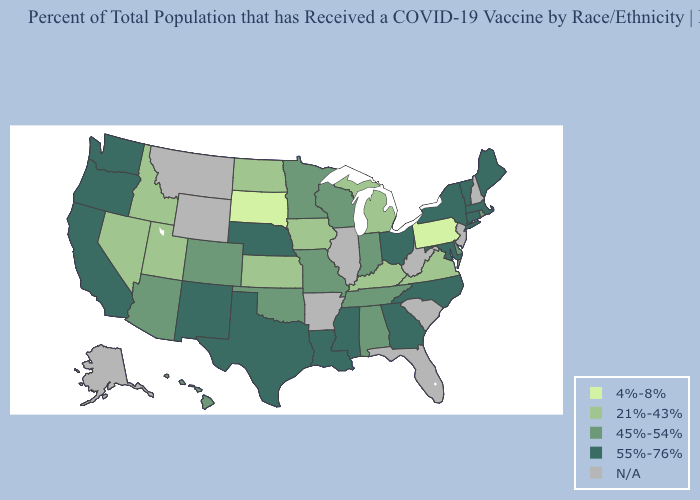Does Vermont have the lowest value in the USA?
Answer briefly. No. Does the first symbol in the legend represent the smallest category?
Answer briefly. Yes. What is the lowest value in the USA?
Write a very short answer. 4%-8%. Name the states that have a value in the range 55%-76%?
Concise answer only. California, Connecticut, Georgia, Louisiana, Maine, Maryland, Massachusetts, Mississippi, Nebraska, New Mexico, New York, North Carolina, Ohio, Oregon, Texas, Vermont, Washington. What is the value of Utah?
Concise answer only. 21%-43%. Name the states that have a value in the range 21%-43%?
Answer briefly. Idaho, Iowa, Kansas, Kentucky, Michigan, Nevada, North Dakota, Utah, Virginia. Name the states that have a value in the range 55%-76%?
Be succinct. California, Connecticut, Georgia, Louisiana, Maine, Maryland, Massachusetts, Mississippi, Nebraska, New Mexico, New York, North Carolina, Ohio, Oregon, Texas, Vermont, Washington. What is the lowest value in states that border Utah?
Keep it brief. 21%-43%. Which states have the lowest value in the South?
Quick response, please. Kentucky, Virginia. Among the states that border Idaho , does Oregon have the highest value?
Give a very brief answer. Yes. What is the value of Idaho?
Quick response, please. 21%-43%. What is the value of Montana?
Write a very short answer. N/A. Which states hav the highest value in the South?
Give a very brief answer. Georgia, Louisiana, Maryland, Mississippi, North Carolina, Texas. 